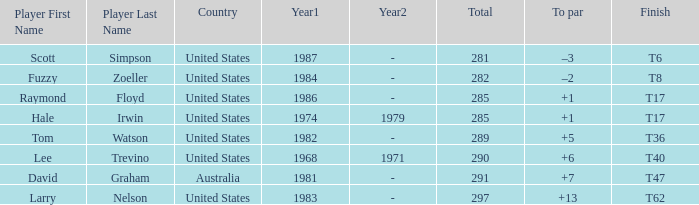What player has a total of 290 points? Lee Trevino. 